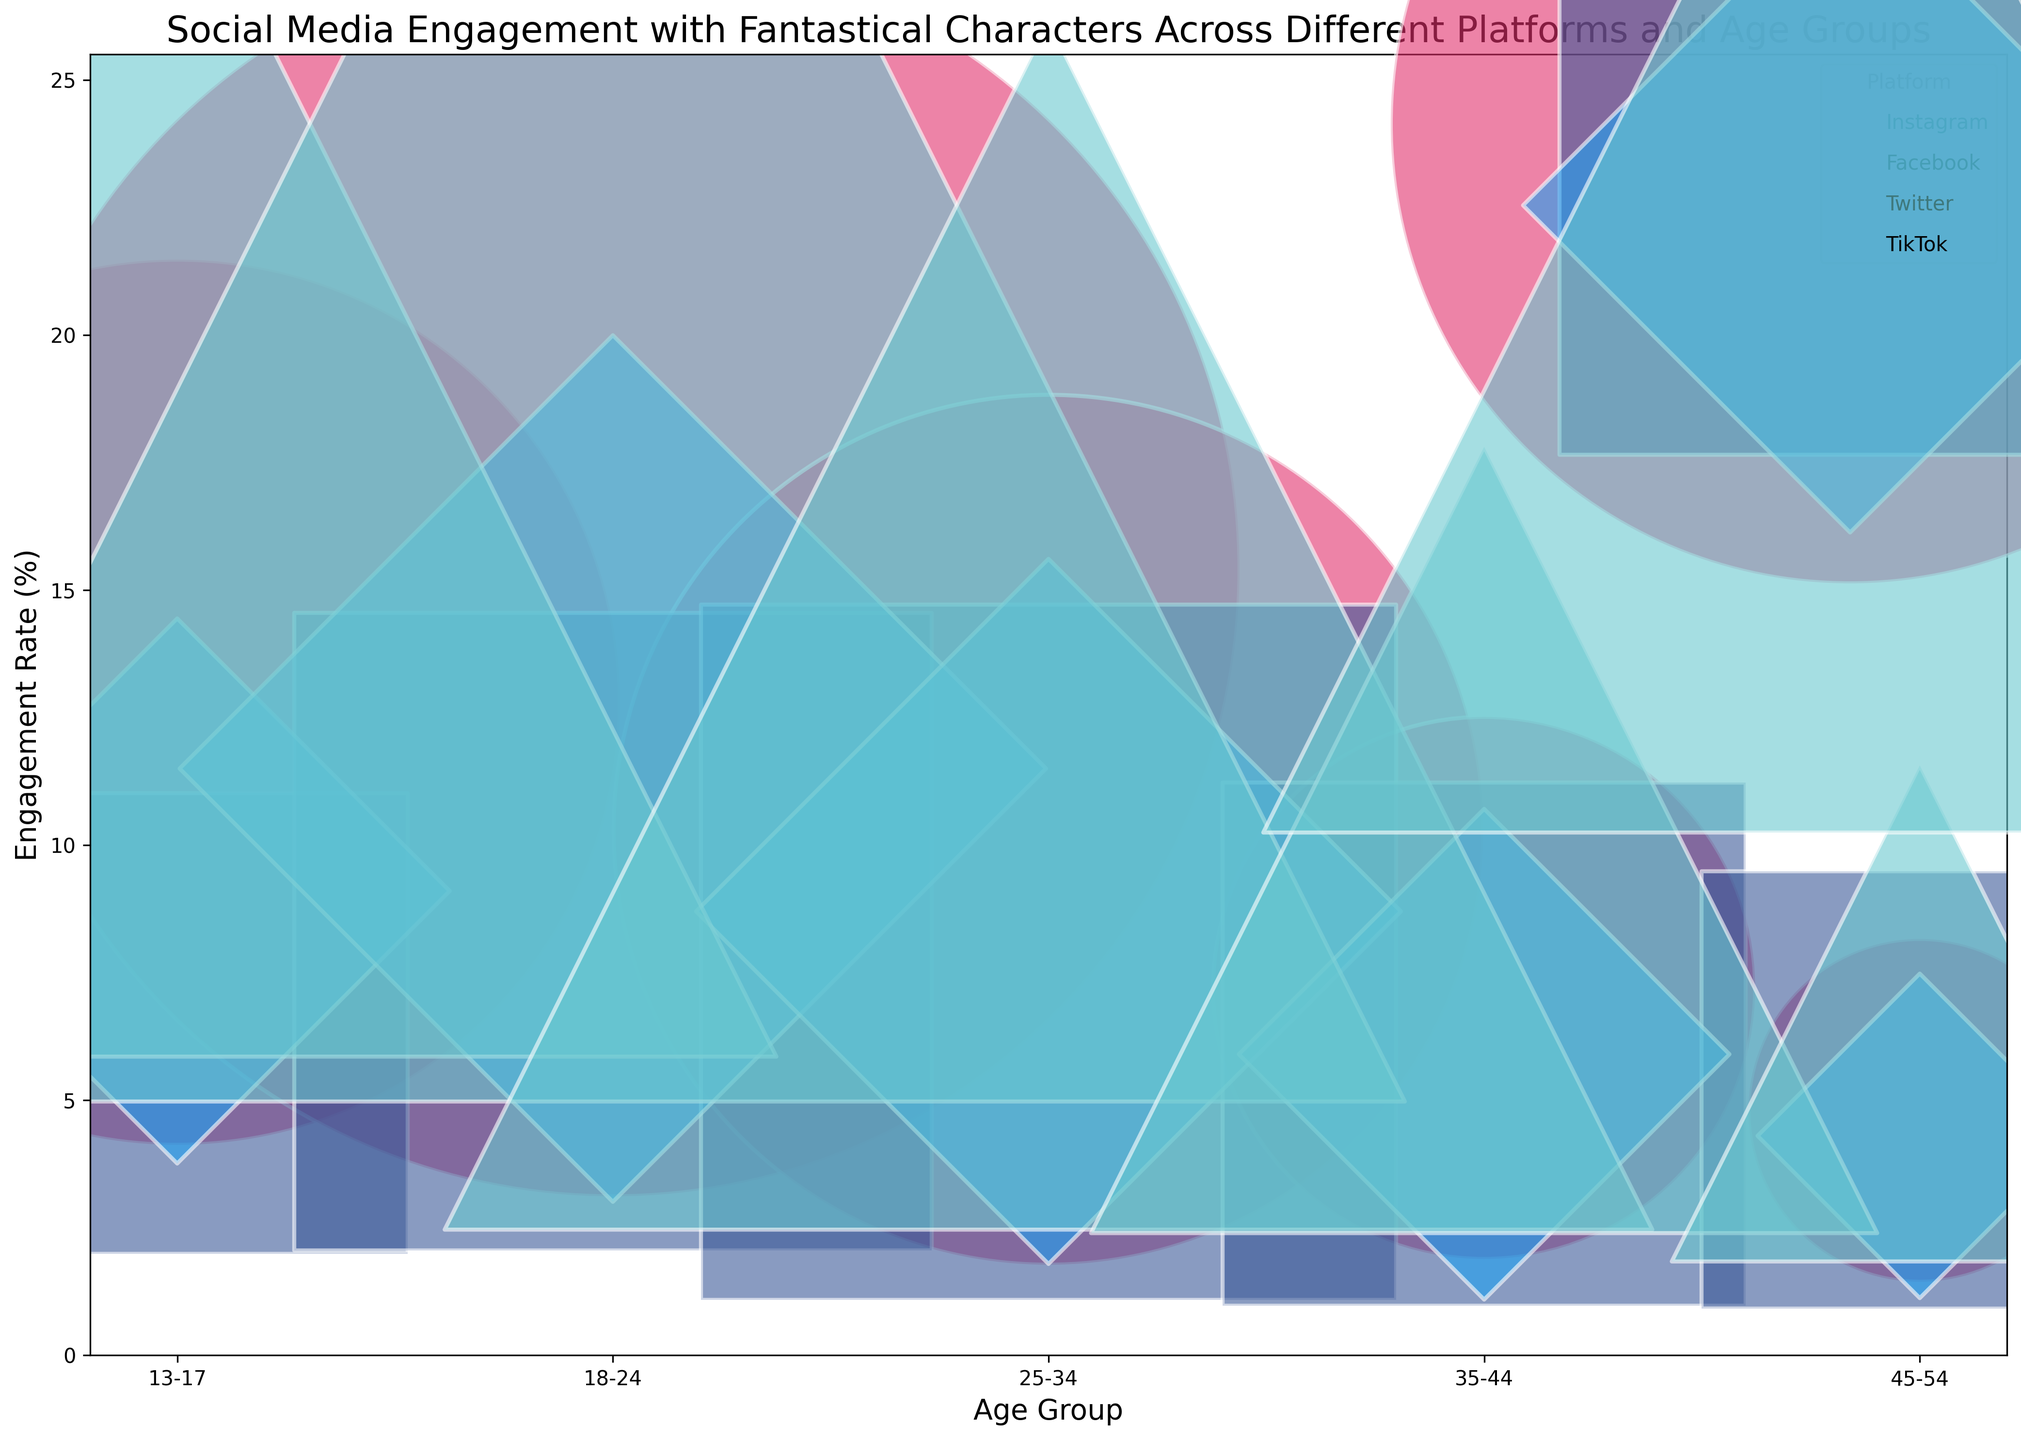What platform has the highest engagement rate in the 18-24 age group? To determine the platform with the highest engagement rate for the 18-24 age group, look at the engagement rates of each platform's bubble for that age group. TikTok has the highest engagement rate of 20.5%.
Answer: TikTok Which age group has the lowest engagement rate on Twitter? Check the engagement rates for all age groups on Twitter by finding the respective bubbles. The 45-54 age group has the lowest engagement rate on Twitter at 4.3%.
Answer: 45-54 Compare the engagement rates between Instagram and TikTok for the 13-17 age group. Which platform has a higher engagement rate and by how much? Locate the bubbles for the 13-17 age group on both Instagram and TikTok and compare their engagement rates. Instagram has a 12.8% engagement rate while TikTok has 17.6%. The difference is 17.6% - 12.8% = 4.8%.
Answer: TikTok by 4.8% What is the average engagement rate for Facebook across all age groups? Add up the engagement rates for all listed age groups on Facebook, then divide by the number of age groups. (6.5% + 8.3% + 7.9% + 6.1% + 5.2%) / 5 = 34% / 5 = 6.8%
Answer: 6.8% Which platform has the largest bubble size in the 25-34 age group, and what does that signify? Identify the largest bubble for the 25-34 age group and note the platform. TikTok's bubble is the largest. This signifies the highest follower count relative to engagement rate in this age group.
Answer: TikTok How does the engagement rate for the 35-44 age group on Instagram compare to Facebook? Compare the engagement rates for both platforms in the 35-44 age group by finding their bubbles. Instagram has a 7.2% engagement rate while Facebook has 6.1%. Instagram's rate is higher by 1.1%.
Answer: Instagram by 1.1% Rank the platforms by engagement rate for the 18-24 age group from highest to lowest. Compare the engagement rates for each platform's bubble in the 18-24 age group. TikTok (20.5%), Instagram (15.4%), Twitter (11.5%), Facebook (8.3%).
Answer: TikTok, Instagram, Twitter, Facebook What is the total follower count for the 13-17 age group across all platforms? Sum the follower counts for the 13-17 age group across all platforms. 1,500,000 (Instagram) + 800,000 (Facebook) + 400,000 (Twitter) + 2,000,000 (TikTok) = 4,700,000
Answer: 4,700,000 For the 25-34 age group, which platform has the smallest bubble size and what does it indicate? Identify the smallest bubble size for the 25-34 age group and note the platform. Twitter's bubble is the smallest. This indicates the lowest follower count relative to engagement rate in this age group.
Answer: Twitter 